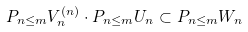<formula> <loc_0><loc_0><loc_500><loc_500>\L P _ { n \leq m } V _ { n } ^ { ( n ) } \cdot \L P _ { n \leq m } U _ { n } \subset \L P _ { n \leq m } W _ { n }</formula> 